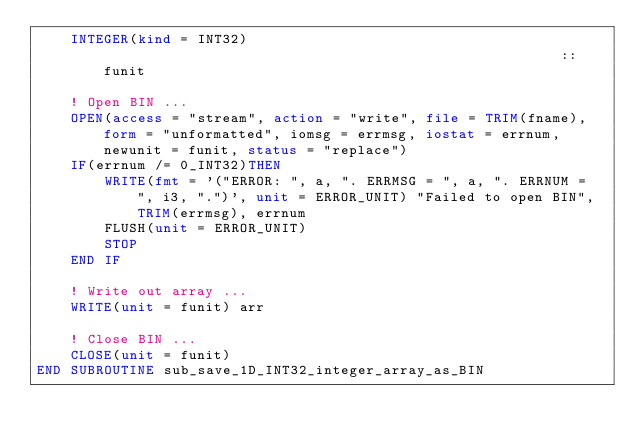Convert code to text. <code><loc_0><loc_0><loc_500><loc_500><_FORTRAN_>    INTEGER(kind = INT32)                                                       :: funit

    ! Open BIN ...
    OPEN(access = "stream", action = "write", file = TRIM(fname), form = "unformatted", iomsg = errmsg, iostat = errnum, newunit = funit, status = "replace")
    IF(errnum /= 0_INT32)THEN
        WRITE(fmt = '("ERROR: ", a, ". ERRMSG = ", a, ". ERRNUM = ", i3, ".")', unit = ERROR_UNIT) "Failed to open BIN", TRIM(errmsg), errnum
        FLUSH(unit = ERROR_UNIT)
        STOP
    END IF

    ! Write out array ...
    WRITE(unit = funit) arr

    ! Close BIN ...
    CLOSE(unit = funit)
END SUBROUTINE sub_save_1D_INT32_integer_array_as_BIN
</code> 